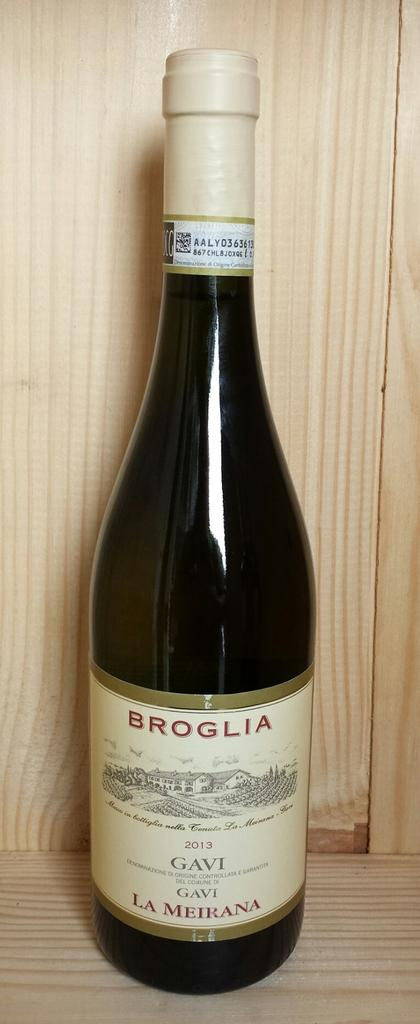<image>
Describe the image concisely. A dark bottle of Broglia wine with a beige cap is on the wooden shelf. 